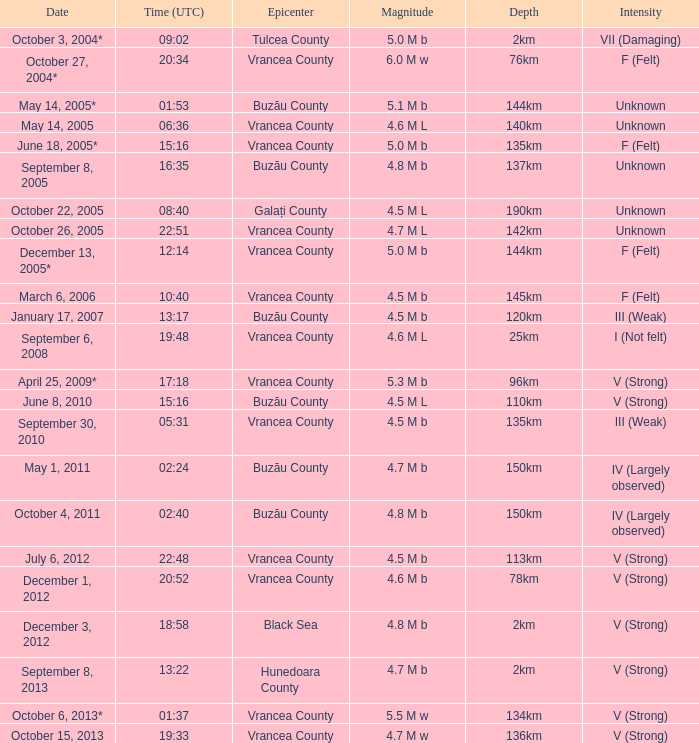What is the depth of the quake that occurred at 19:48? 25km. 